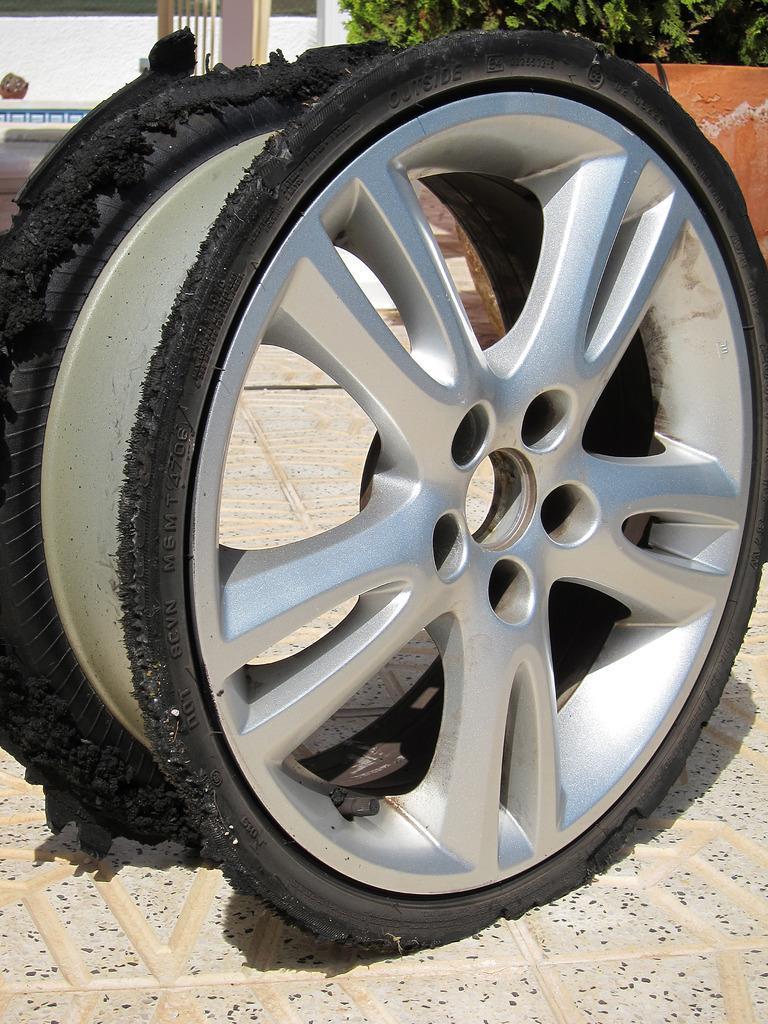Describe this image in one or two sentences. In the foreground of the picture we can see rim on the floor. In the background there are tree, wall and other objects. 